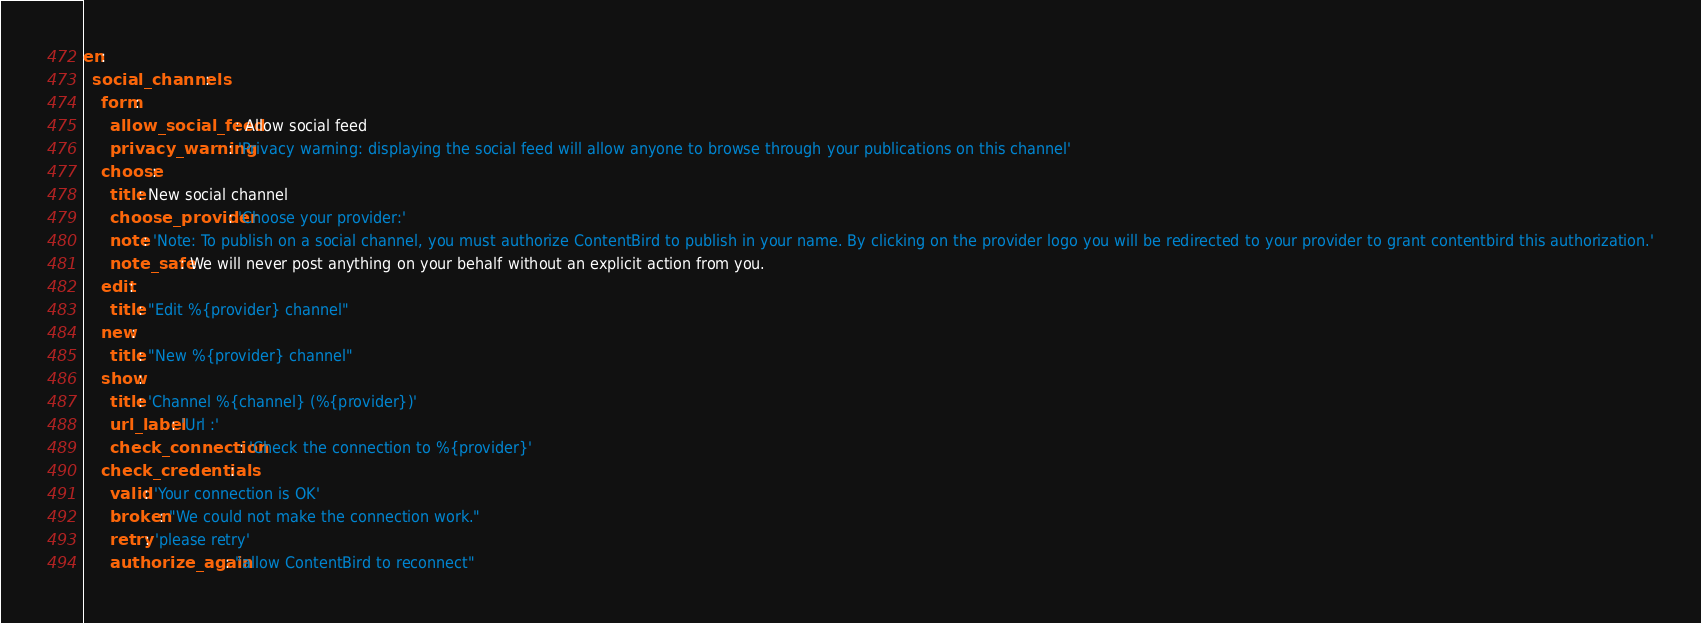Convert code to text. <code><loc_0><loc_0><loc_500><loc_500><_YAML_>en:
  social_channels:
    form:
      allow_social_feed: Allow social feed
      privacy_warning: 'Privacy warning: displaying the social feed will allow anyone to browse through your publications on this channel'
    choose:
      title: New social channel
      choose_provider: 'Choose your provider:'
      note: 'Note: To publish on a social channel, you must authorize ContentBird to publish in your name. By clicking on the provider logo you will be redirected to your provider to grant contentbird this authorization.'
      note_safe: We will never post anything on your behalf without an explicit action from you.
    edit:
      title: "Edit %{provider} channel"
    new:
      title: "New %{provider} channel"
    show:
      title: 'Channel %{channel} (%{provider})'
      url_label: 'Url :'
      check_connection: 'Check the connection to %{provider}'
    check_credentials:
      valid: 'Your connection is OK'
      broken: "We could not make the connection work."
      retry: 'please retry'
      authorize_again: "allow ContentBird to reconnect"</code> 